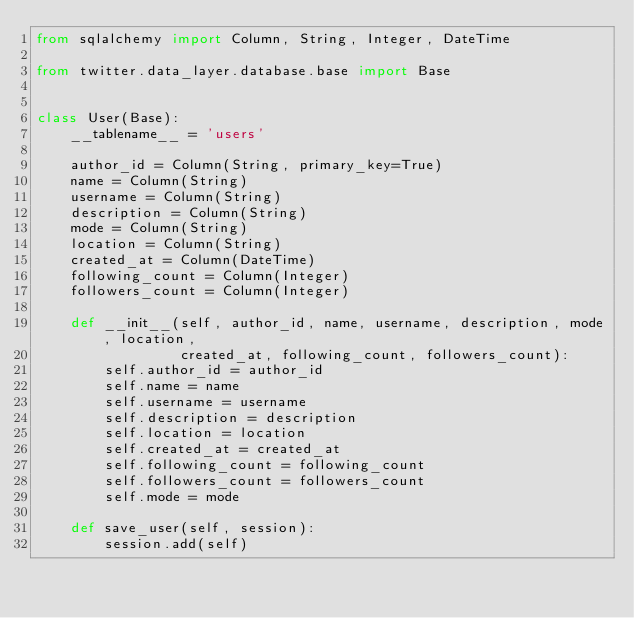Convert code to text. <code><loc_0><loc_0><loc_500><loc_500><_Python_>from sqlalchemy import Column, String, Integer, DateTime

from twitter.data_layer.database.base import Base


class User(Base):
    __tablename__ = 'users'

    author_id = Column(String, primary_key=True)
    name = Column(String)
    username = Column(String)
    description = Column(String)
    mode = Column(String)
    location = Column(String)
    created_at = Column(DateTime)
    following_count = Column(Integer)
    followers_count = Column(Integer)

    def __init__(self, author_id, name, username, description, mode, location,
                 created_at, following_count, followers_count):
        self.author_id = author_id
        self.name = name
        self.username = username
        self.description = description
        self.location = location
        self.created_at = created_at
        self.following_count = following_count
        self.followers_count = followers_count
        self.mode = mode

    def save_user(self, session):
        session.add(self)
</code> 